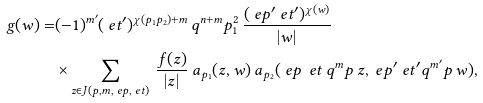<formula> <loc_0><loc_0><loc_500><loc_500>g ( w ) = & ( - 1 ) ^ { m ^ { \prime } } ( \ e t ^ { \prime } ) ^ { \chi ( p _ { 1 } p _ { 2 } ) + m } \, q ^ { n + m } p _ { 1 } ^ { 2 } \, \frac { ( \ e p ^ { \prime } \ e t ^ { \prime } ) ^ { \chi ( w ) } } { | w | } \\ & \times \sum _ { z \in J ( p , m , \ e p , \ e t ) } \, \frac { f ( z ) } { | z | } \, a _ { p _ { 1 } } ( z , w ) \, a _ { p _ { 2 } } ( \ e p \, \ e t \, q ^ { m } p \, z , \ e p ^ { \prime } \ e t ^ { \prime } q ^ { m ^ { \prime } } p \, w ) ,</formula> 